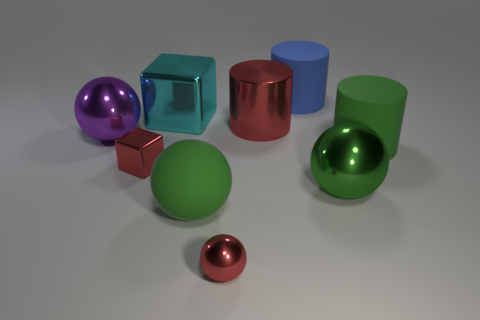Do the red metallic ball that is in front of the large red object and the block in front of the green matte cylinder have the same size?
Give a very brief answer. Yes. There is a big green thing that is the same shape as the blue object; what is it made of?
Make the answer very short. Rubber. How many small objects are red shiny blocks or purple spheres?
Your answer should be compact. 1. What is the blue object made of?
Provide a short and direct response. Rubber. What is the material of the big ball that is both on the left side of the big red metallic cylinder and right of the big cyan metal thing?
Your answer should be compact. Rubber. There is a tiny ball; does it have the same color as the cube in front of the green matte cylinder?
Make the answer very short. Yes. There is a blue cylinder that is the same size as the rubber sphere; what is its material?
Your answer should be compact. Rubber. Is there a red object that has the same material as the tiny red sphere?
Give a very brief answer. Yes. How many small metallic things are there?
Provide a short and direct response. 2. Does the red ball have the same material as the large green object that is left of the big blue cylinder?
Keep it short and to the point. No. 